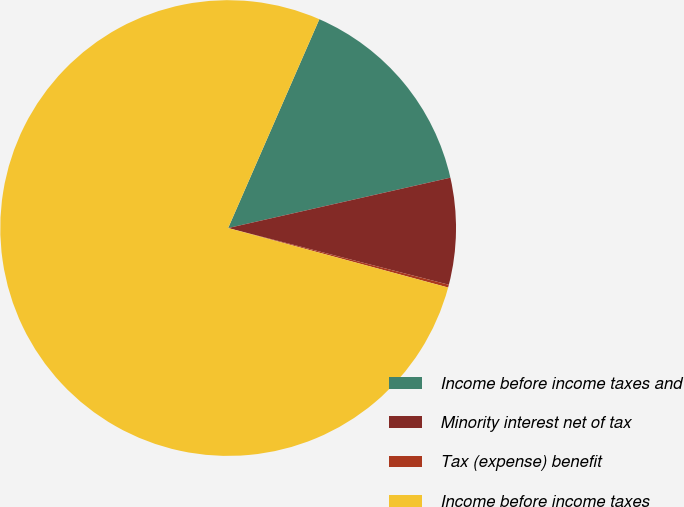<chart> <loc_0><loc_0><loc_500><loc_500><pie_chart><fcel>Income before income taxes and<fcel>Minority interest net of tax<fcel>Tax (expense) benefit<fcel>Income before income taxes<nl><fcel>14.9%<fcel>7.55%<fcel>0.2%<fcel>77.35%<nl></chart> 